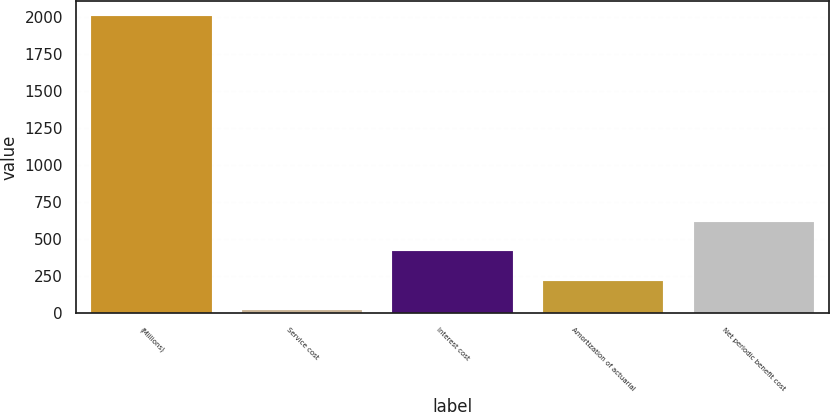Convert chart to OTSL. <chart><loc_0><loc_0><loc_500><loc_500><bar_chart><fcel>(Millions)<fcel>Service cost<fcel>Interest cost<fcel>Amortization of actuarial<fcel>Net periodic benefit cost<nl><fcel>2004<fcel>22<fcel>418.4<fcel>220.2<fcel>616.6<nl></chart> 